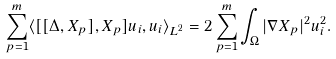<formula> <loc_0><loc_0><loc_500><loc_500>\sum _ { p = 1 } ^ { m } \langle [ [ \Delta , X _ { p } ] , X _ { p } ] u _ { i } , u _ { i } \rangle _ { L ^ { 2 } } = 2 \sum _ { p = 1 } ^ { m } \int _ { \Omega } | \nabla X _ { p } | ^ { 2 } u _ { i } ^ { 2 } .</formula> 